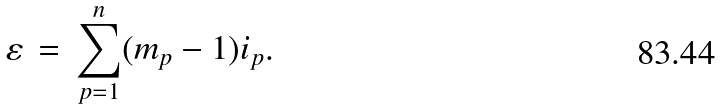<formula> <loc_0><loc_0><loc_500><loc_500>\varepsilon \, = \, \sum _ { p = 1 } ^ { n } ( m _ { p } - 1 ) i _ { p } .</formula> 